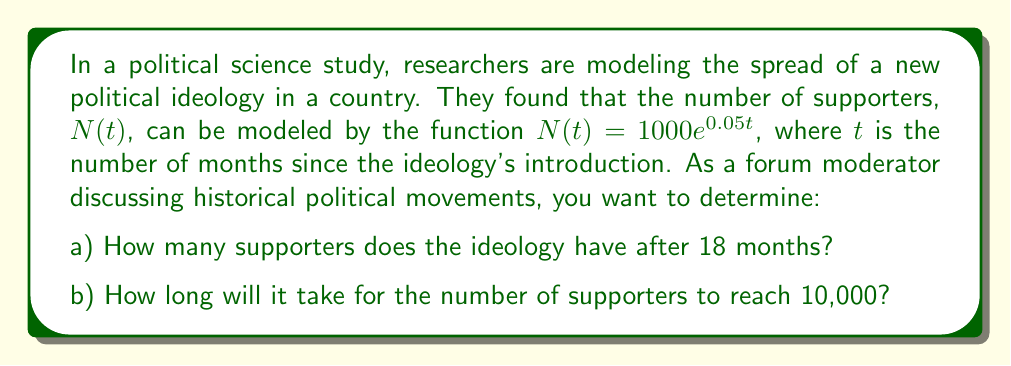Give your solution to this math problem. Let's approach this problem step-by-step:

a) To find the number of supporters after 18 months, we simply need to substitute $t=18$ into the given function:

   $N(18) = 1000e^{0.05(18)}$
   
   $= 1000e^{0.9}$
   
   $\approx 2459.6$

   Therefore, after 18 months, the ideology has approximately 2,460 supporters.

b) To find when the number of supporters reaches 10,000, we need to solve the equation:

   $10000 = 1000e^{0.05t}$

   Dividing both sides by 1000:
   
   $10 = e^{0.05t}$

   Taking the natural logarithm of both sides:
   
   $\ln(10) = 0.05t$

   Solving for $t$:
   
   $t = \frac{\ln(10)}{0.05} \approx 46.05$

   Therefore, it will take approximately 46.05 months for the number of supporters to reach 10,000.

This exponential growth model demonstrates how political ideologies can spread rapidly over time, which is a common phenomenon observed in historical political movements.
Answer: a) 2,460 supporters (rounded to the nearest whole number)
b) 46.05 months 